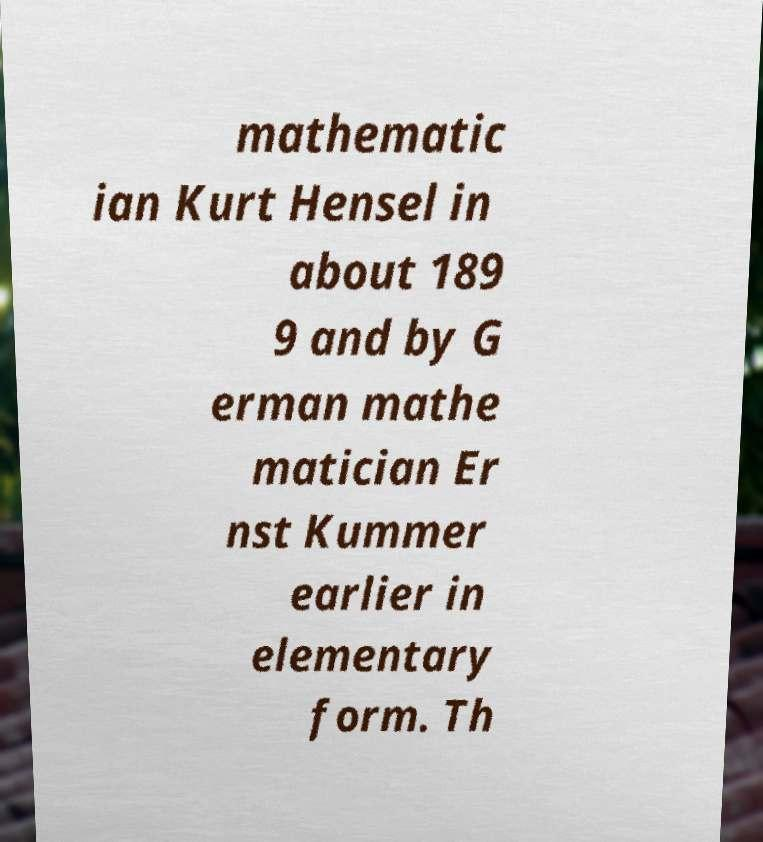Can you read and provide the text displayed in the image?This photo seems to have some interesting text. Can you extract and type it out for me? mathematic ian Kurt Hensel in about 189 9 and by G erman mathe matician Er nst Kummer earlier in elementary form. Th 